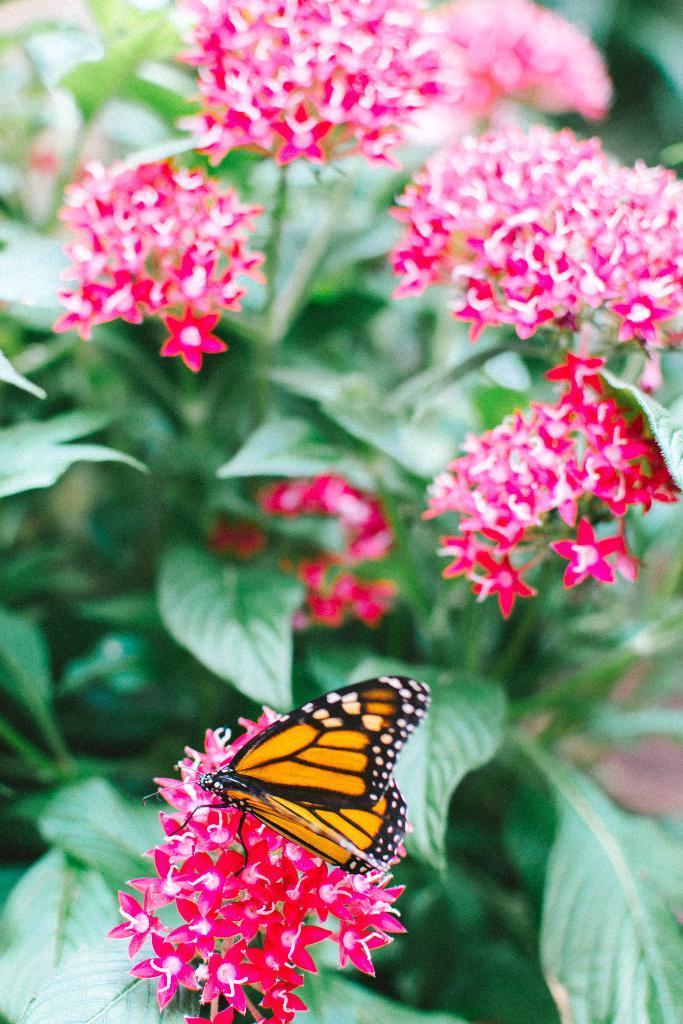Could you give a brief overview of what you see in this image? In this image I can see a butterfly. In the background, I can see the flowers on the plants. 